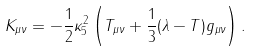Convert formula to latex. <formula><loc_0><loc_0><loc_500><loc_500>K _ { \mu \nu } = - \frac { 1 } { 2 } \kappa ^ { 2 } _ { 5 } \left ( T _ { \mu \nu } + \frac { 1 } { 3 } ( \lambda - T ) g _ { \mu \nu } \right ) .</formula> 